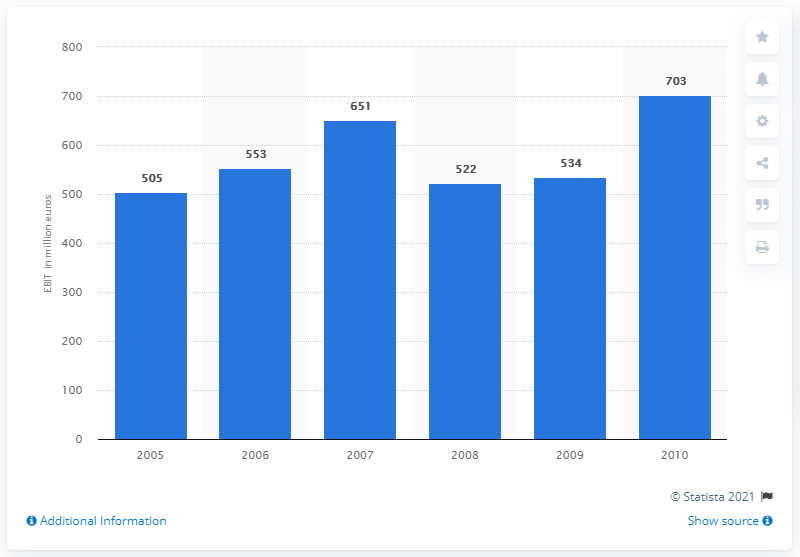Point out several critical features in this image. The EBIT (Earnings Before Interest and Taxes) of the BSH Group in 2010 was 703. 